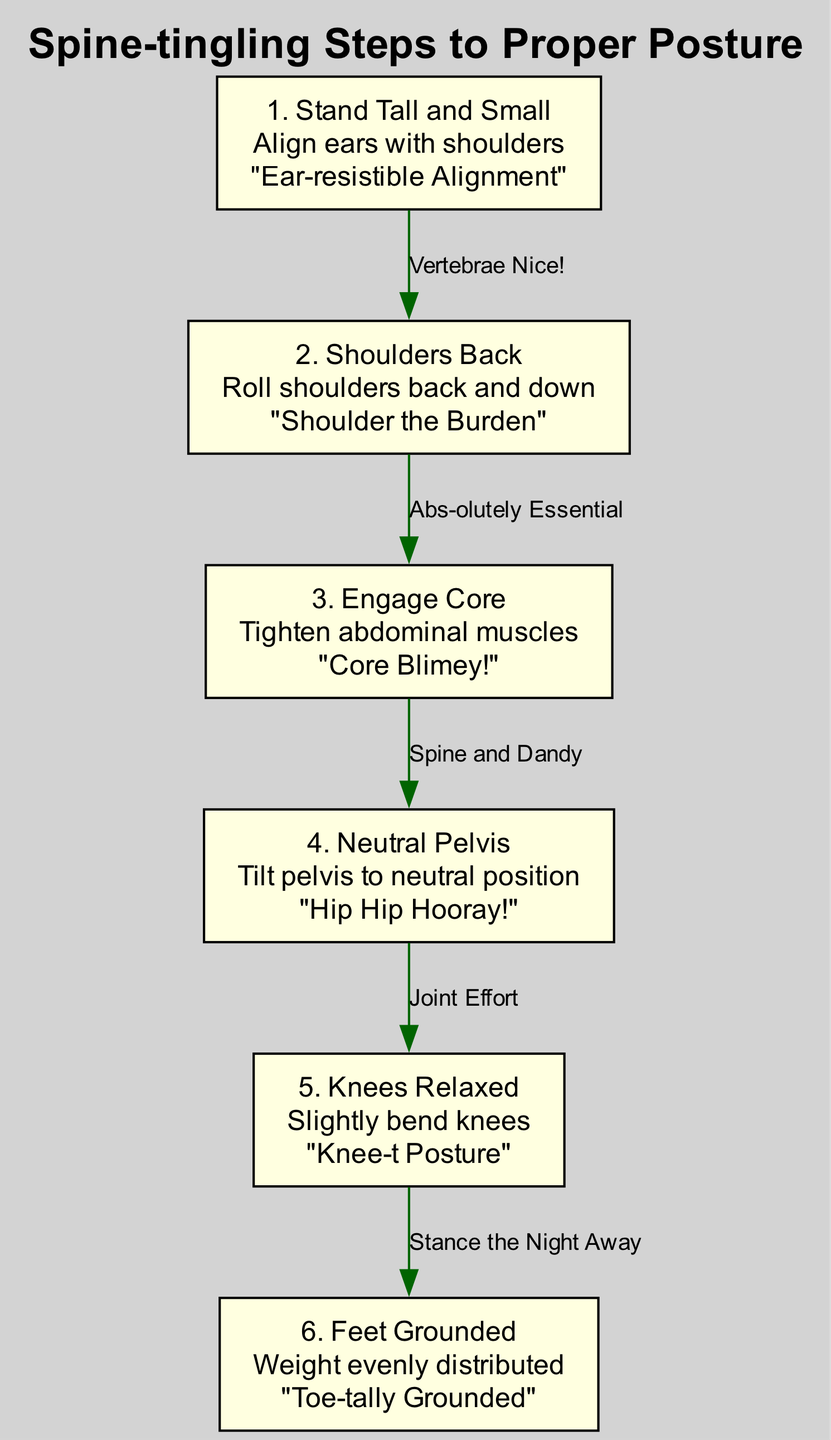What is the first step for proper posture alignment? The first step listed in the diagram is titled "Stand Tall and Small", which involves aligning ears with shoulders. This indicates that this is the starting point for achieving proper posture, as it emphasizes the importance of head alignment.
Answer: Stand Tall and Small What pun accompanies the second step? The second step is called "Shoulders Back," and its accompanying pun is "Shoulder the Burden." This is explicitly stated under the description of step 2 in the diagram.
Answer: Shoulder the Burden How many steps are there in total? The diagram lists six distinct steps under the "Spine-tingling Steps to Proper Posture," hence the total number of steps is 6.
Answer: 6 What is the relationship between step 4 and step 5? The arrow connecting step 4 "Neutral Pelvis" to step 5 "Knees Relaxed" is labeled "Joint Effort." This indicates that there's a relationship between the proper positioning of the pelvis and the relaxation of the knees in maintaining good posture.
Answer: Joint Effort Which step involves tightening the abdominal muscles? The step that focuses on tightening the abdominal muscles is labeled "Engage Core," which is clearly specified as step 3 in the diagram. This step is crucial for supporting overall posture stability.
Answer: Engage Core What is the description for the last step? The last step in the diagram, labeled "Feet Grounded," has the description "Weight evenly distributed." This indicates the importance of distributing weight properly for maintaining balance while standing.
Answer: Weight evenly distributed Which step is referred to by the pun "Core Blimey!"? The pun "Core Blimey!" is associated with step 3, which focuses on engaging the core by tightening the abdominal muscles. This phrase creatively emphasizes the critical nature of core engagement in posture maintenance.
Answer: Engage Core How do steps 2 and 3 connect in the flow? The connection from step 2 "Shoulders Back" to step 3 "Engage Core" is labeled "Abs-olutely Essential." This indicates that after adjusting the shoulders, engaging the core is vital, highlighting a sequence in improving posture effectively.
Answer: Abs-olutely Essential 